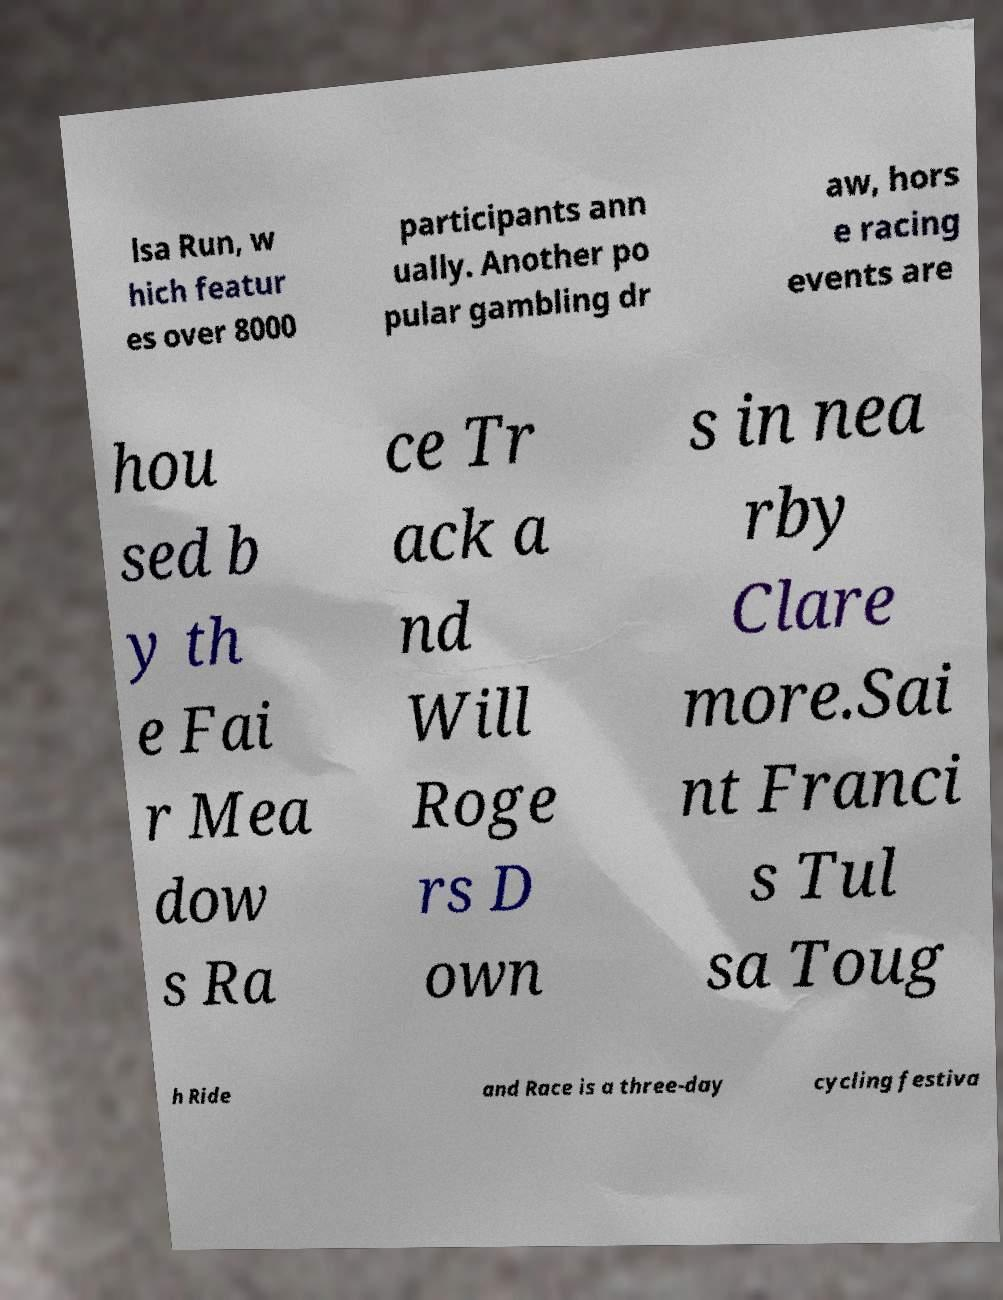Please read and relay the text visible in this image. What does it say? lsa Run, w hich featur es over 8000 participants ann ually. Another po pular gambling dr aw, hors e racing events are hou sed b y th e Fai r Mea dow s Ra ce Tr ack a nd Will Roge rs D own s in nea rby Clare more.Sai nt Franci s Tul sa Toug h Ride and Race is a three-day cycling festiva 